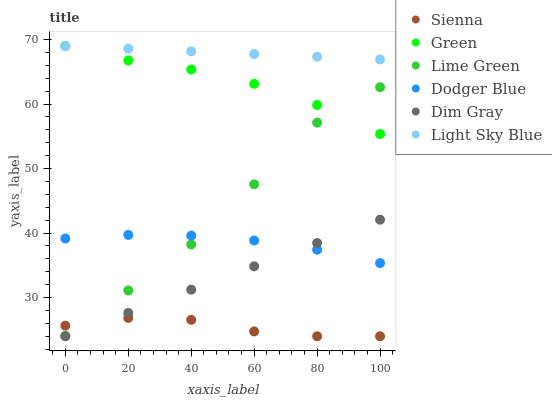Does Sienna have the minimum area under the curve?
Answer yes or no. Yes. Does Light Sky Blue have the maximum area under the curve?
Answer yes or no. Yes. Does Light Sky Blue have the minimum area under the curve?
Answer yes or no. No. Does Sienna have the maximum area under the curve?
Answer yes or no. No. Is Dim Gray the smoothest?
Answer yes or no. Yes. Is Lime Green the roughest?
Answer yes or no. Yes. Is Sienna the smoothest?
Answer yes or no. No. Is Sienna the roughest?
Answer yes or no. No. Does Dim Gray have the lowest value?
Answer yes or no. Yes. Does Light Sky Blue have the lowest value?
Answer yes or no. No. Does Green have the highest value?
Answer yes or no. Yes. Does Sienna have the highest value?
Answer yes or no. No. Is Dodger Blue less than Green?
Answer yes or no. Yes. Is Light Sky Blue greater than Dodger Blue?
Answer yes or no. Yes. Does Dodger Blue intersect Dim Gray?
Answer yes or no. Yes. Is Dodger Blue less than Dim Gray?
Answer yes or no. No. Is Dodger Blue greater than Dim Gray?
Answer yes or no. No. Does Dodger Blue intersect Green?
Answer yes or no. No. 